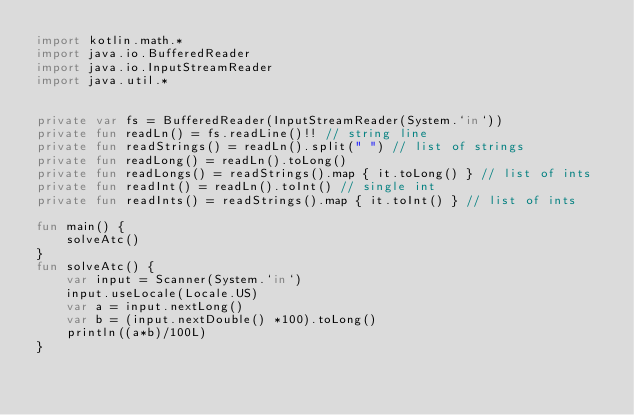<code> <loc_0><loc_0><loc_500><loc_500><_Kotlin_>import kotlin.math.*
import java.io.BufferedReader
import java.io.InputStreamReader
import java.util.*


private var fs = BufferedReader(InputStreamReader(System.`in`))
private fun readLn() = fs.readLine()!! // string line
private fun readStrings() = readLn().split(" ") // list of strings
private fun readLong() = readLn().toLong()
private fun readLongs() = readStrings().map { it.toLong() } // list of ints
private fun readInt() = readLn().toInt() // single int
private fun readInts() = readStrings().map { it.toInt() } // list of ints

fun main() {
    solveAtc()
}
fun solveAtc() {
    var input = Scanner(System.`in`)
    input.useLocale(Locale.US)
    var a = input.nextLong()
    var b = (input.nextDouble() *100).toLong()
    println((a*b)/100L)
}
</code> 